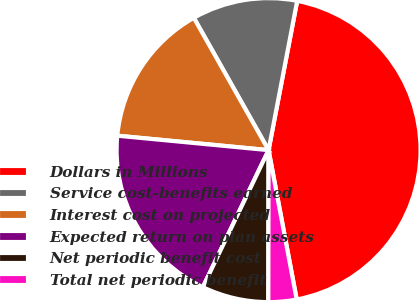Convert chart. <chart><loc_0><loc_0><loc_500><loc_500><pie_chart><fcel>Dollars in Millions<fcel>Service cost-benefits earned<fcel>Interest cost on projected<fcel>Expected return on plan assets<fcel>Net periodic benefit cost<fcel>Total net periodic benefit<nl><fcel>44.02%<fcel>11.2%<fcel>15.3%<fcel>19.4%<fcel>7.09%<fcel>2.99%<nl></chart> 